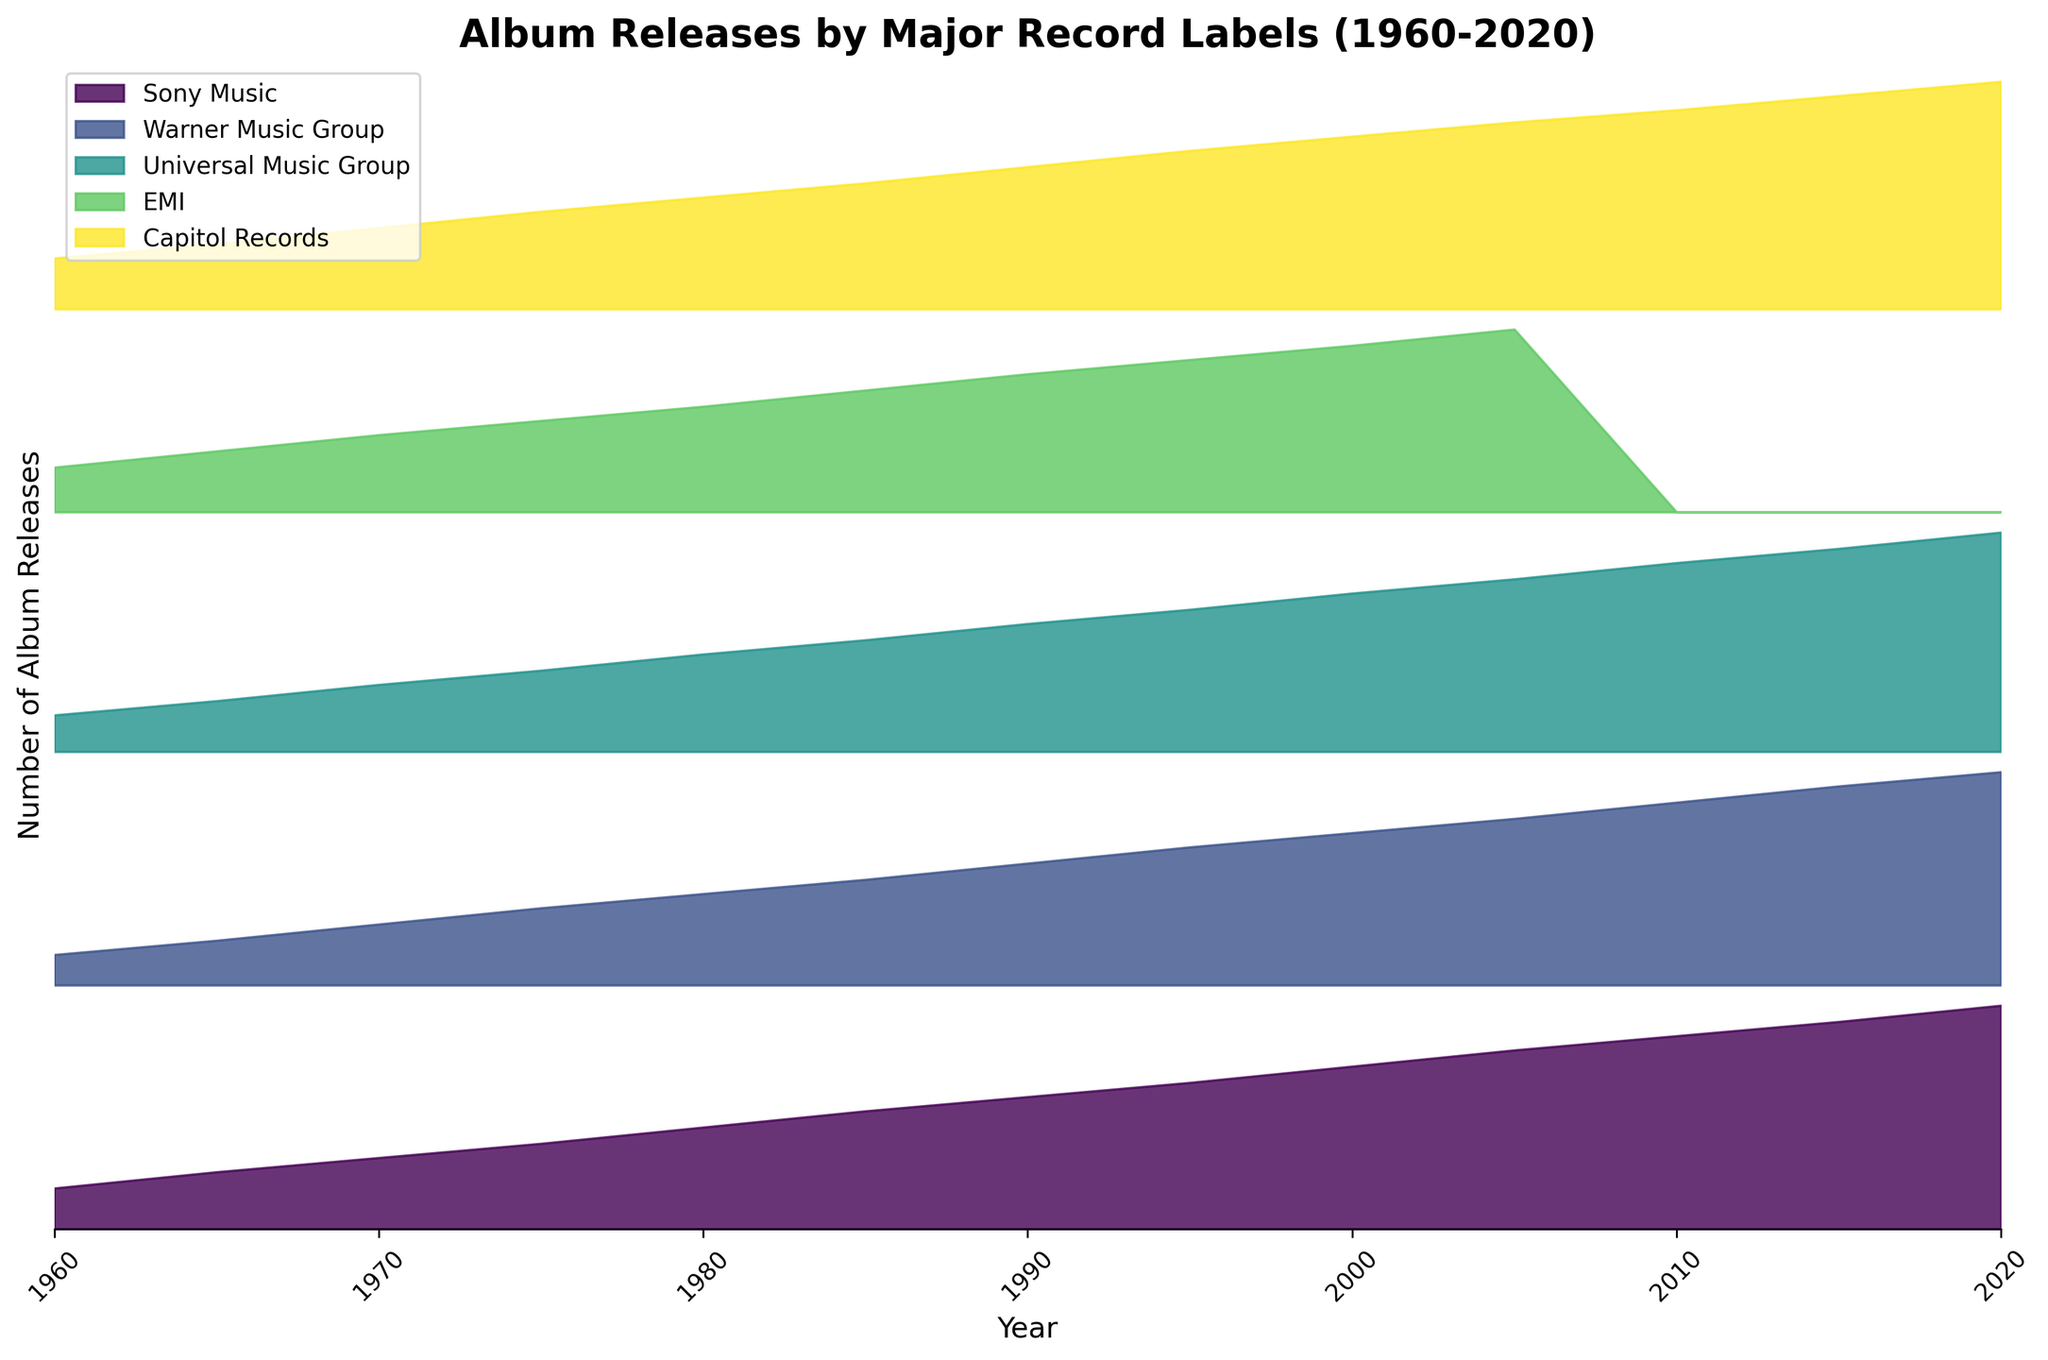What are the major record labels shown in the figure? The labels can be identified from the legend on the right side of the figure, which lists: Sony Music, Warner Music Group, Universal Music Group, EMI, and Capitol Records.
Answer: Sony Music, Warner Music Group, Universal Music Group, EMI, Capitol Records Which record label shows the highest number of album releases in 1980? Focus on the year 1980 and compare the heights of each label's section. Capitol Records has the highest peak in that year.
Answer: Capitol Records What is the overall trend for album releases from 1960 to 2020? Observe the rising trends for the lines representing each label from the left side of the plot (1960) to the right side (2020). The general trend is an increase in album releases over time.
Answer: Increasing In which year did EMI stop releasing albums? Look for the point in time where EMI's filled region stops appearing, which is after 2010.
Answer: After 2010 How many years are covered in the figure? The x-axis ticks show years starting from 1960 and ending at 2020, so we count the number of intervals including both end points.
Answer: 61 years By how much did the album releases by Sony Music increase between 1960 and 2020? Identify and subtract the 1960 value of Sony Music from the 2020 value: 110 - 20 = 90.
Answer: 90 Which label had the steepest increase in album releases between 1960 and 2000? Compare the slopes of each label's section for the years between 1960 and 2000. Sony Music shows the steepest increase.
Answer: Sony Music What is the difference in the number of releases for Warner Music Group between 1985 and 2015? Identify the values for Warner Music Group in 1985 (52) and 2015 (98) and find the difference: 98 - 52 = 46.
Answer: 46 How does the growth trend of Capitol Records differ from Universal Music Group around the year 2000? Compare the heights and trends for Capitol Records and Universal Music Group around the year 2000. Capitol Records continues to rise steadily while Universal Music Group has a more gradual slope.
Answer: Steadier for Capitol Records, more gradual for Universal Music Group Which label had the most consistent growth from 1960 to 2020? Consistent growth can be interpreted as a steady increase over time without sharp changes. Observing the plot, Warner Music Group shows the most consistent growth.
Answer: Warner Music Group 